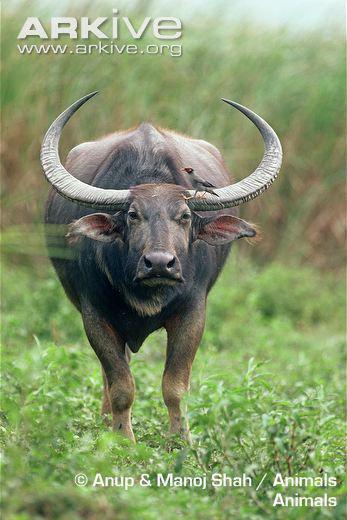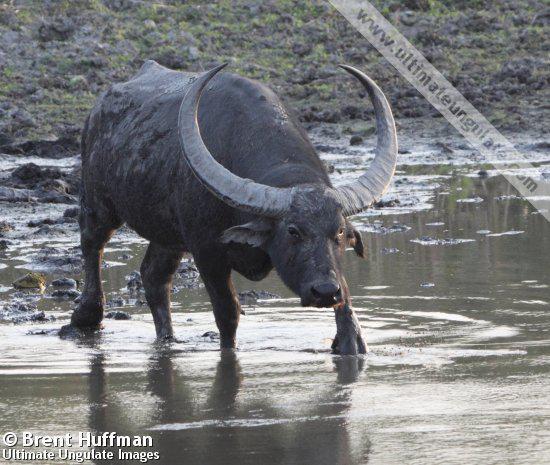The first image is the image on the left, the second image is the image on the right. Evaluate the accuracy of this statement regarding the images: "In each image the water buffalo's horns are completely visible.". Is it true? Answer yes or no. Yes. The first image is the image on the left, the second image is the image on the right. For the images shown, is this caption "The horned animal on the left looks directly at the camera." true? Answer yes or no. Yes. 